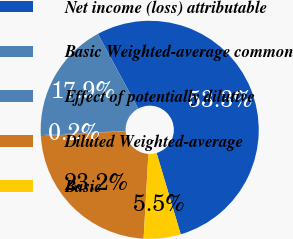Convert chart. <chart><loc_0><loc_0><loc_500><loc_500><pie_chart><fcel>Net income (loss) attributable<fcel>Basic Weighted-average common<fcel>Effect of potentially dilutive<fcel>Diluted Weighted-average<fcel>Basic<nl><fcel>53.29%<fcel>17.88%<fcel>0.16%<fcel>23.19%<fcel>5.48%<nl></chart> 